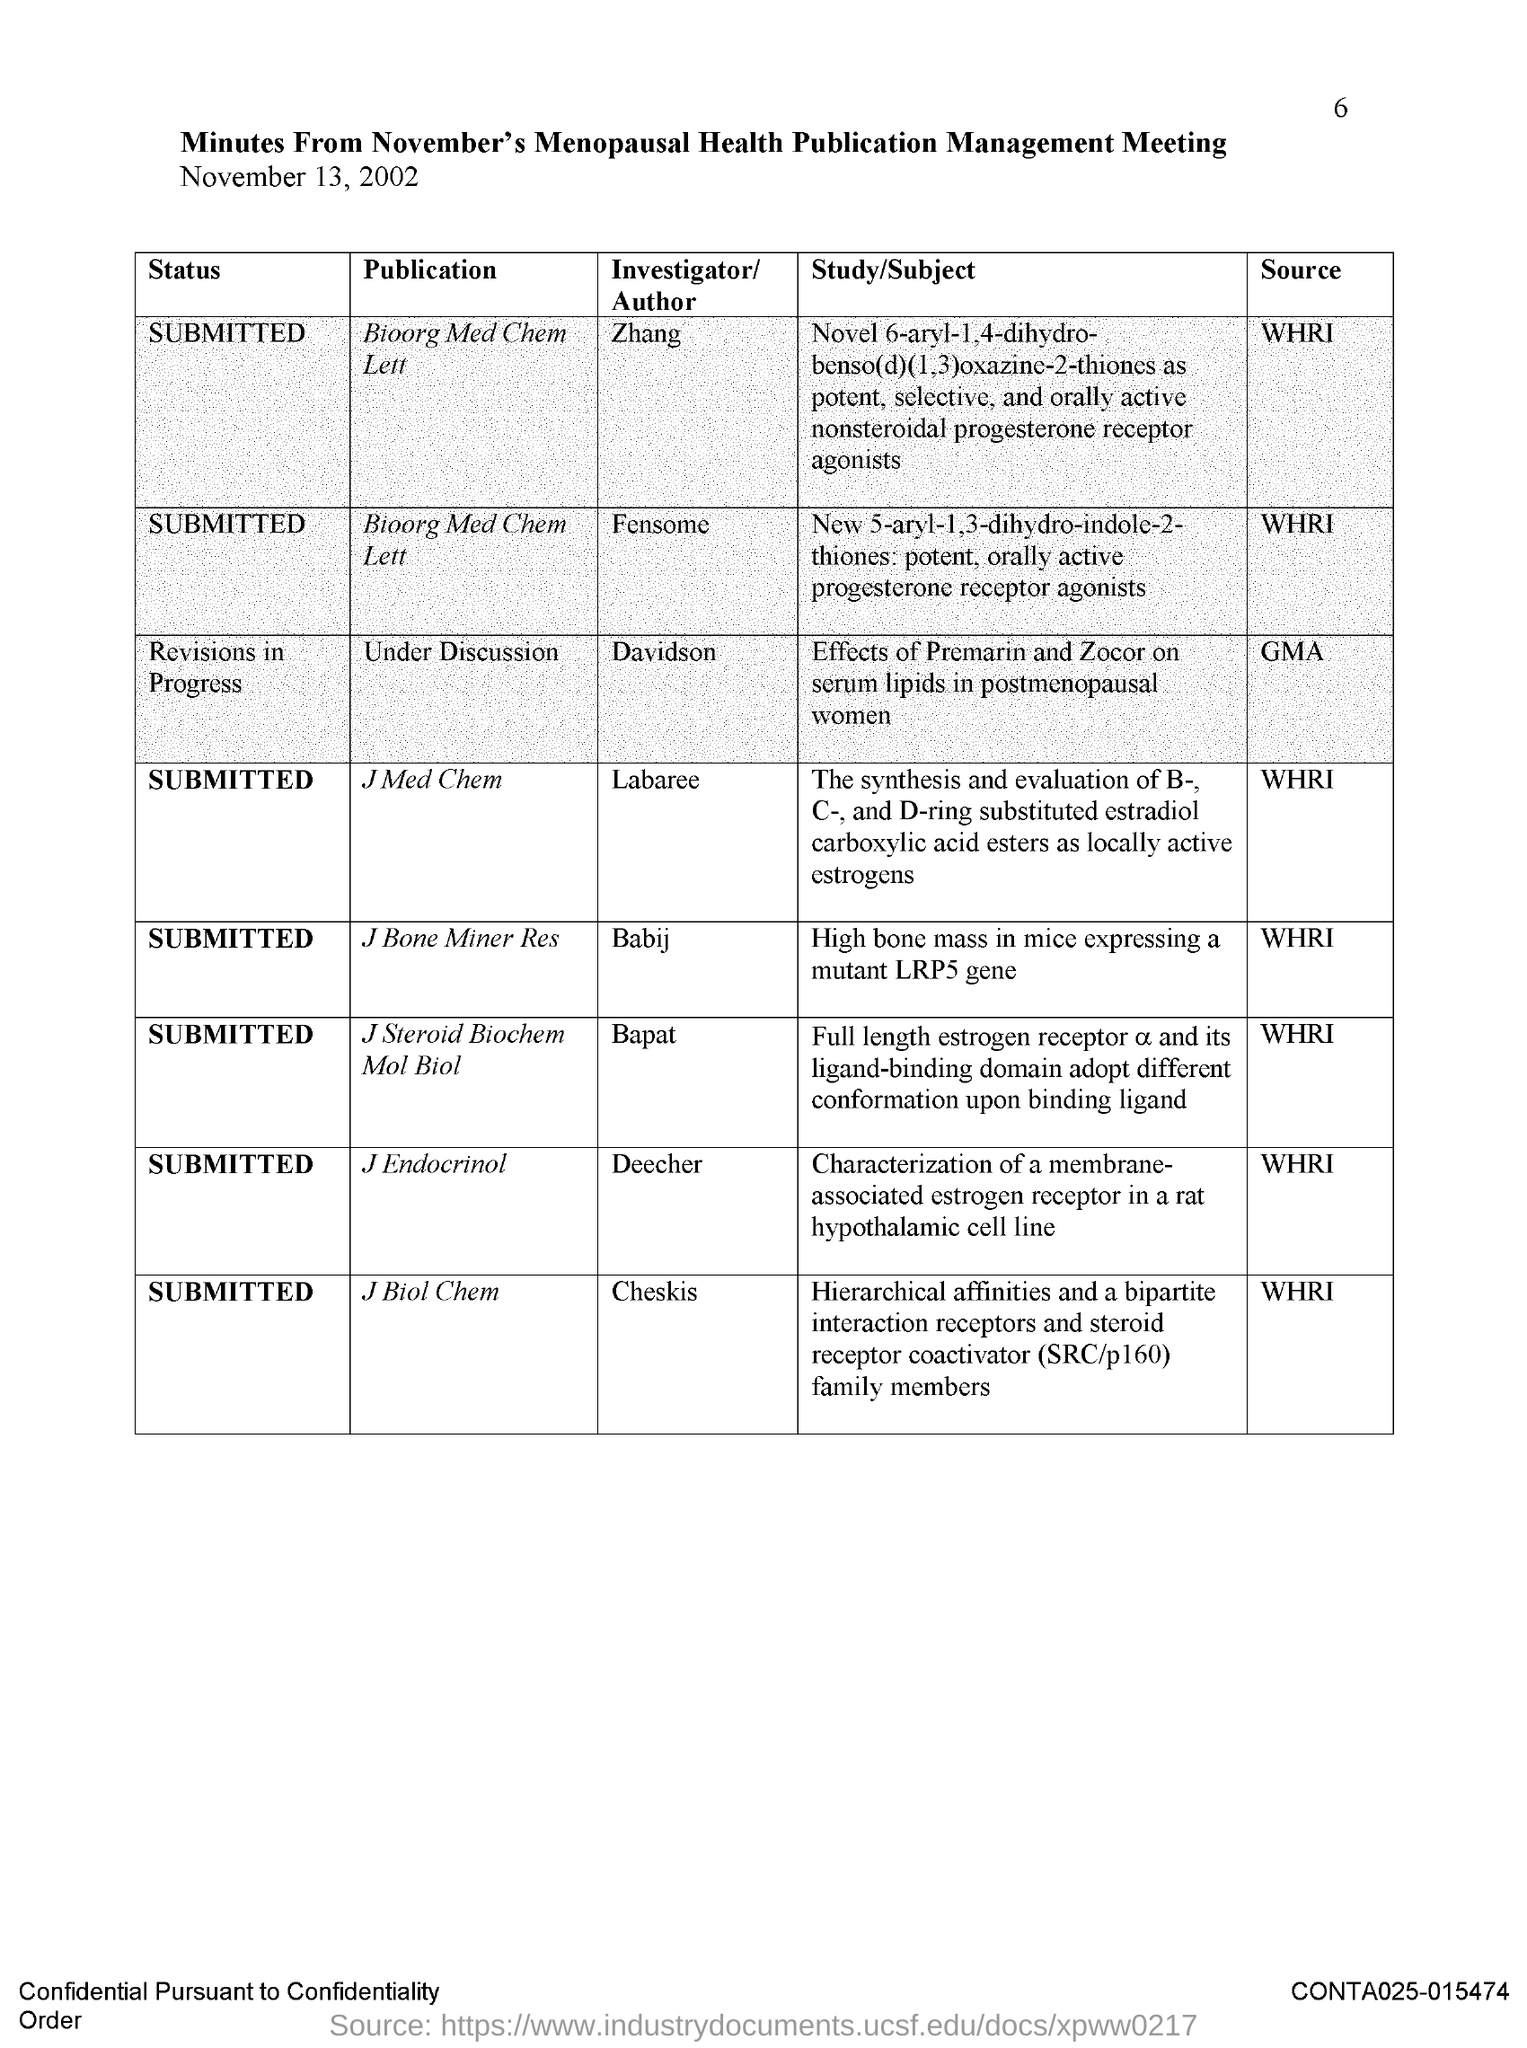What is the title?
Your answer should be compact. MINUTES FROM NOVEMBER'S MENOPAUSAL HEALTH PUBLICATION MANAGEMENT MEETING. What is the date of the meeting?
Your answer should be very brief. November 13, 2002. What is the heading for the first column?
Ensure brevity in your answer.  Status. Who is the investigator/author for bioorg med chem lett?
Offer a very short reply. ZHANG. What is the status of J Med Chem?
Offer a very short reply. Submitted. What is the source of the article submitted in J Biol Chem?
Keep it short and to the point. WHRI. 